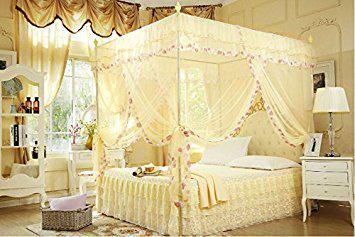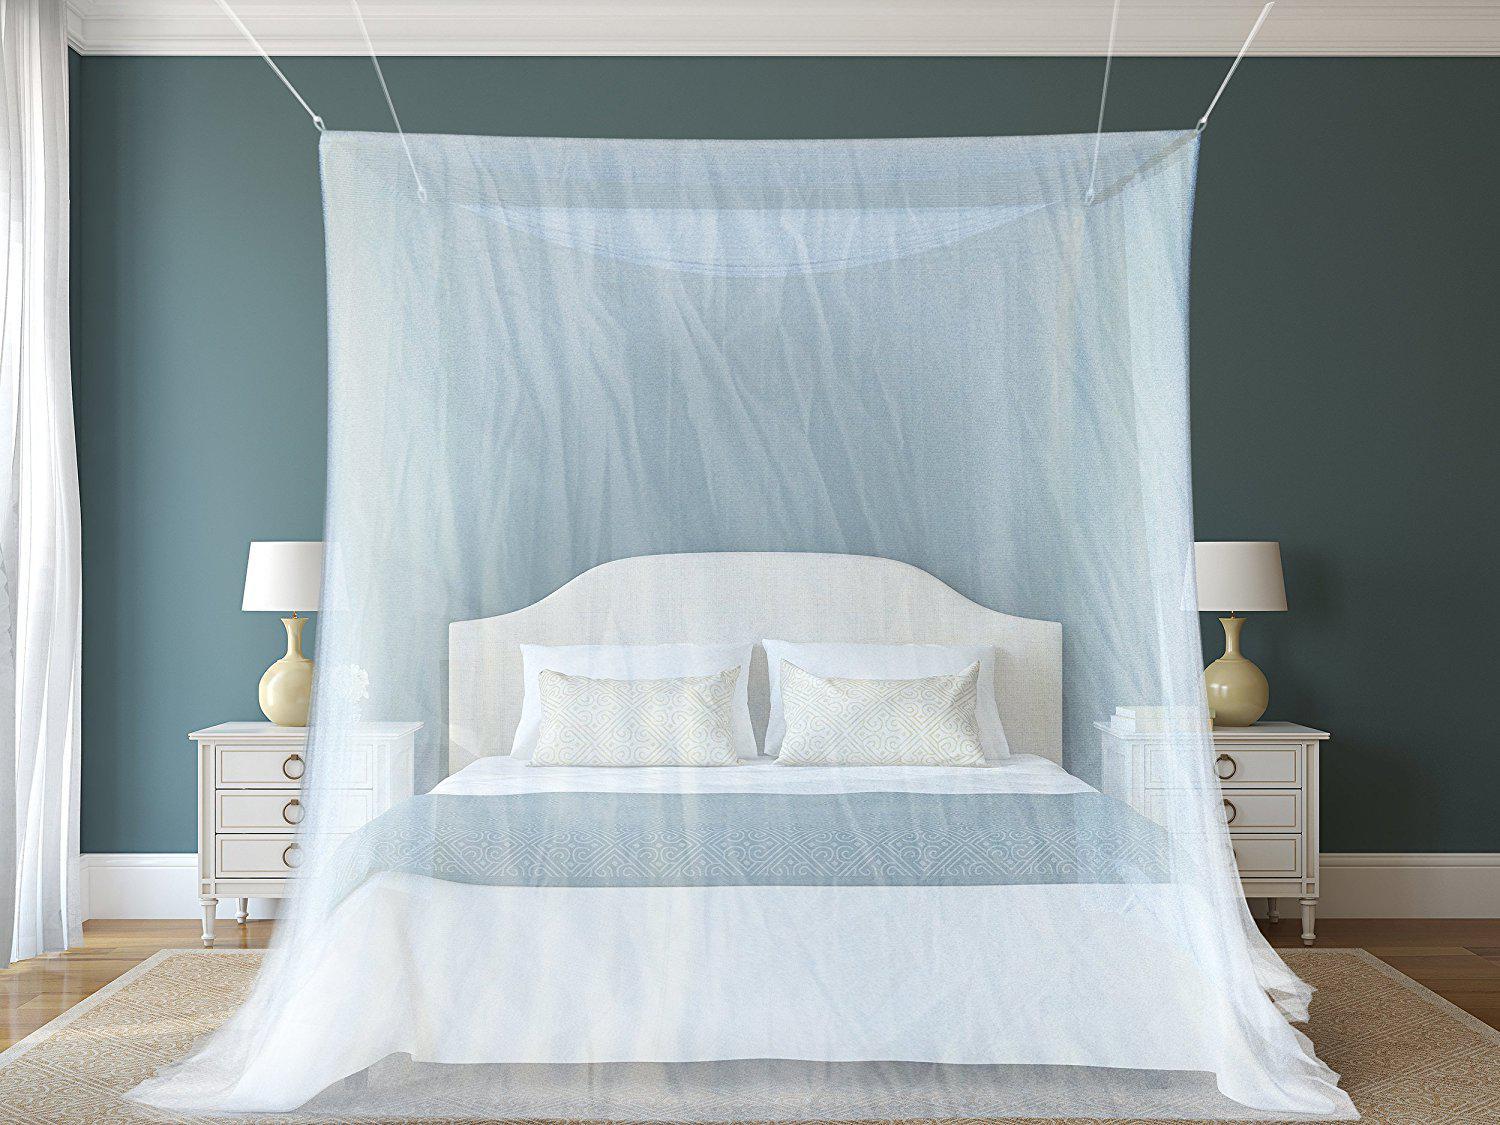The first image is the image on the left, the second image is the image on the right. Examine the images to the left and right. Is the description "In one image, a bed is shown with a lacy, tiered yellow gold bedspread with matching draperies overhead." accurate? Answer yes or no. Yes. 